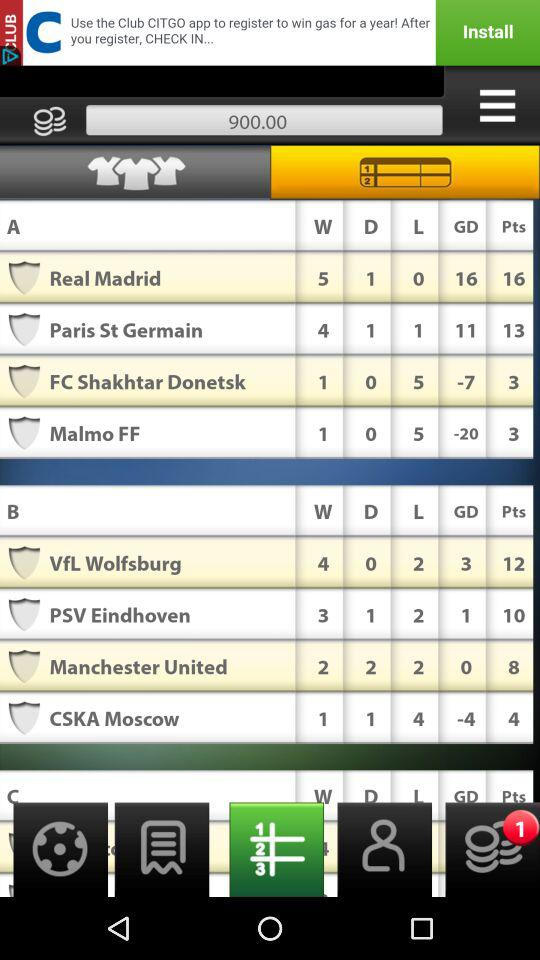How many more points does Real Madrid have than CSKA Moscow?
Answer the question using a single word or phrase. 12 